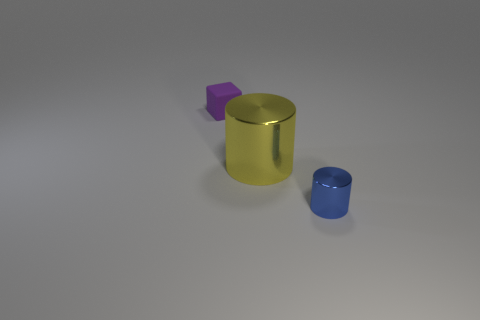There is a small blue cylinder that is in front of the metal cylinder behind the blue metal object; are there any yellow cylinders that are in front of it?
Your response must be concise. No. How many matte things are cubes or large brown blocks?
Give a very brief answer. 1. Do the big metallic object and the tiny shiny object have the same color?
Offer a very short reply. No. What number of tiny things are in front of the small purple rubber thing?
Provide a short and direct response. 1. How many objects are on the right side of the small purple block and behind the blue metallic thing?
Ensure brevity in your answer.  1. The blue thing that is the same material as the yellow object is what shape?
Make the answer very short. Cylinder. There is a metallic object to the right of the big yellow shiny cylinder; does it have the same size as the cylinder behind the blue cylinder?
Provide a succinct answer. No. The tiny object that is on the right side of the large yellow cylinder is what color?
Offer a terse response. Blue. There is a tiny object that is in front of the metal cylinder that is behind the tiny blue metallic thing; what is its material?
Keep it short and to the point. Metal. What shape is the purple object?
Offer a very short reply. Cube. 